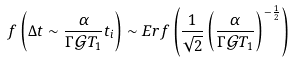<formula> <loc_0><loc_0><loc_500><loc_500>f \left ( \Delta t \sim \frac { \alpha } { \Gamma \mathcal { G } T _ { 1 } } t _ { i } \right ) \sim E r f \left ( \frac { 1 } { \sqrt { 2 } } \left ( \frac { \alpha } { \Gamma \mathcal { G } T _ { 1 } } \right ) ^ { - \frac { 1 } { 2 } } \right )</formula> 